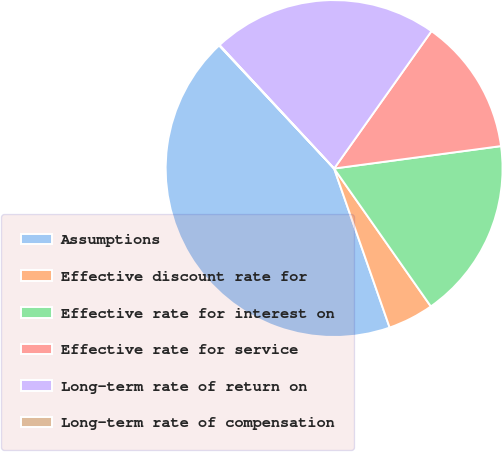Convert chart to OTSL. <chart><loc_0><loc_0><loc_500><loc_500><pie_chart><fcel>Assumptions<fcel>Effective discount rate for<fcel>Effective rate for interest on<fcel>Effective rate for service<fcel>Long-term rate of return on<fcel>Long-term rate of compensation<nl><fcel>43.39%<fcel>4.39%<fcel>17.39%<fcel>13.06%<fcel>21.72%<fcel>0.05%<nl></chart> 